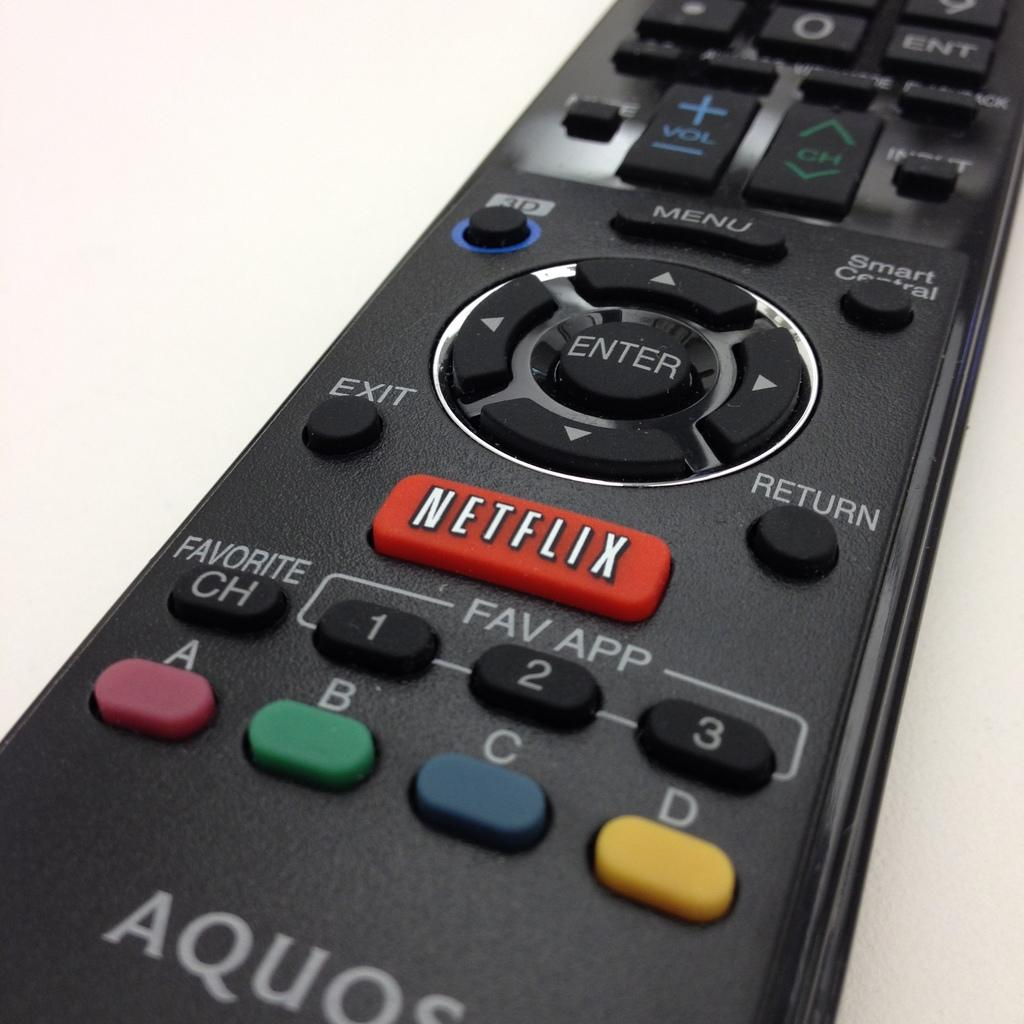<image>
Create a compact narrative representing the image presented. A remote control has a Netflix button that is red. 